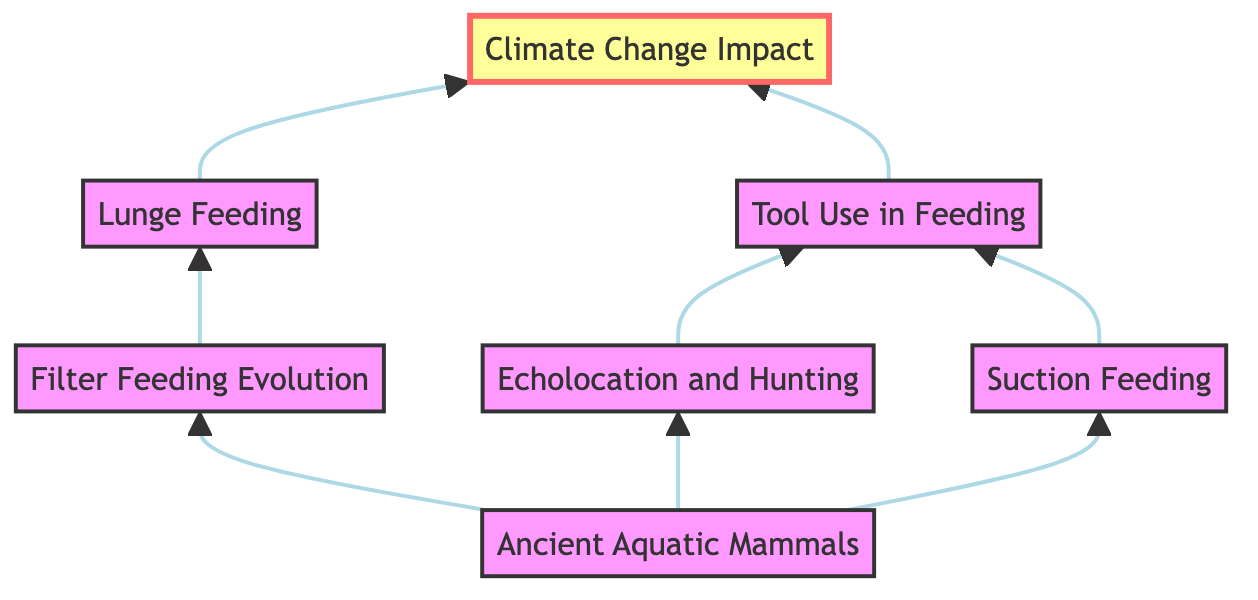What is the top node in the diagram? The top node is the final result of the flowchart, which is indicated by the arrow pointing upwards. In this diagram, the top node is labeled as "Climate Change Impact".
Answer: Climate Change Impact How many nodes are in the diagram? To determine the total number of nodes, we count all unique elements. The elements listed are "Ancient Aquatic Mammals", "Filter Feeding Evolution", "Echolocation and Hunting", "Suction Feeding", "Lunge Feeding", "Tool Use in Feeding", and "Climate Change Impact", leading us to a total of 7 nodes.
Answer: 7 Which feeding strategy develops from "Filter Feeding Evolution"? Following the upward flow of the diagram from "Filter Feeding Evolution", the next node is "Lunge Feeding", which shows a direct relationship.
Answer: Lunge Feeding What relationships exist between "Echolocation and Hunting" and "Tool Use in Feeding"? "Echolocation and Hunting" flows into "Tool Use in Feeding", showing that echolocation strategies can lead to the use of tools in feeding. Both nodes are directly connected through this relationship.
Answer: Direct relationship Which node connects both "Suction Feeding" and "Echolocation and Hunting"? Analyzing the connections in the diagram, both "Suction Feeding" and "Echolocation and Hunting" directly flow into "Tool Use in Feeding", making it the connecting node between them.
Answer: Tool Use in Feeding Which is the first feeding strategy in the evolutionary sequence? The first feeding strategy listed in the diagram is "Ancient Aquatic Mammals", as it is the origin node from which all other strategies develop.
Answer: Ancient Aquatic Mammals What is the significance of the "Climate Change Impact" node in the flowchart? The "Climate Change Impact" node is highlighted in the diagram, indicating its importance as the ultimate outcome influenced by all preceding feeding strategies and their evolution.
Answer: Influence on feeding behaviors How does "Lunge Feeding" relate to "Climate Change Impact"? "Lunge Feeding" leads directly to "Climate Change Impact", showing that this specific feeding strategy is affected by changing environmental conditions, indicating a cause-and-effect relationship.
Answer: Direct influence 